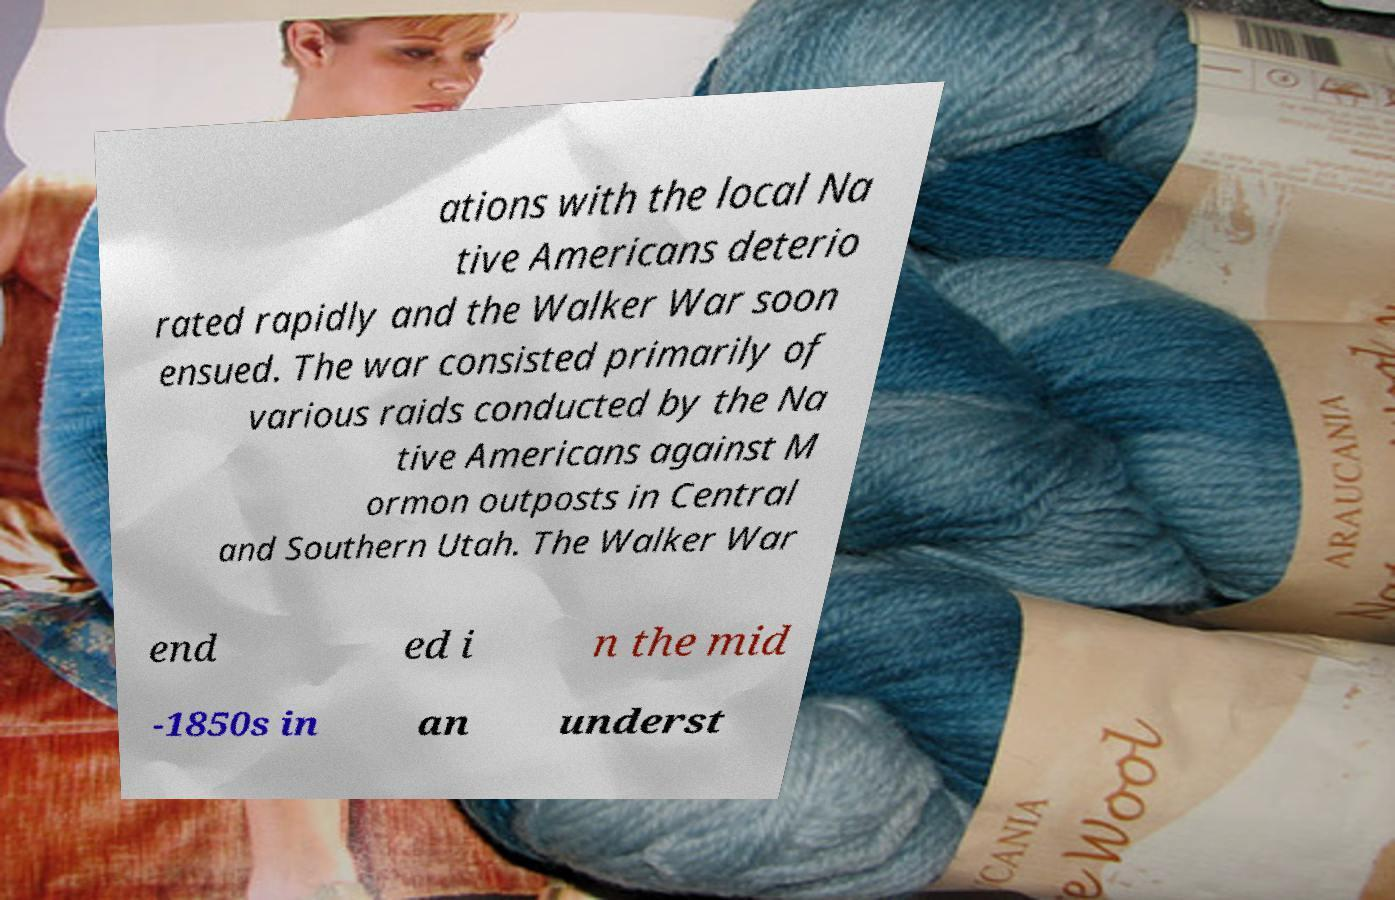Please read and relay the text visible in this image. What does it say? ations with the local Na tive Americans deterio rated rapidly and the Walker War soon ensued. The war consisted primarily of various raids conducted by the Na tive Americans against M ormon outposts in Central and Southern Utah. The Walker War end ed i n the mid -1850s in an underst 